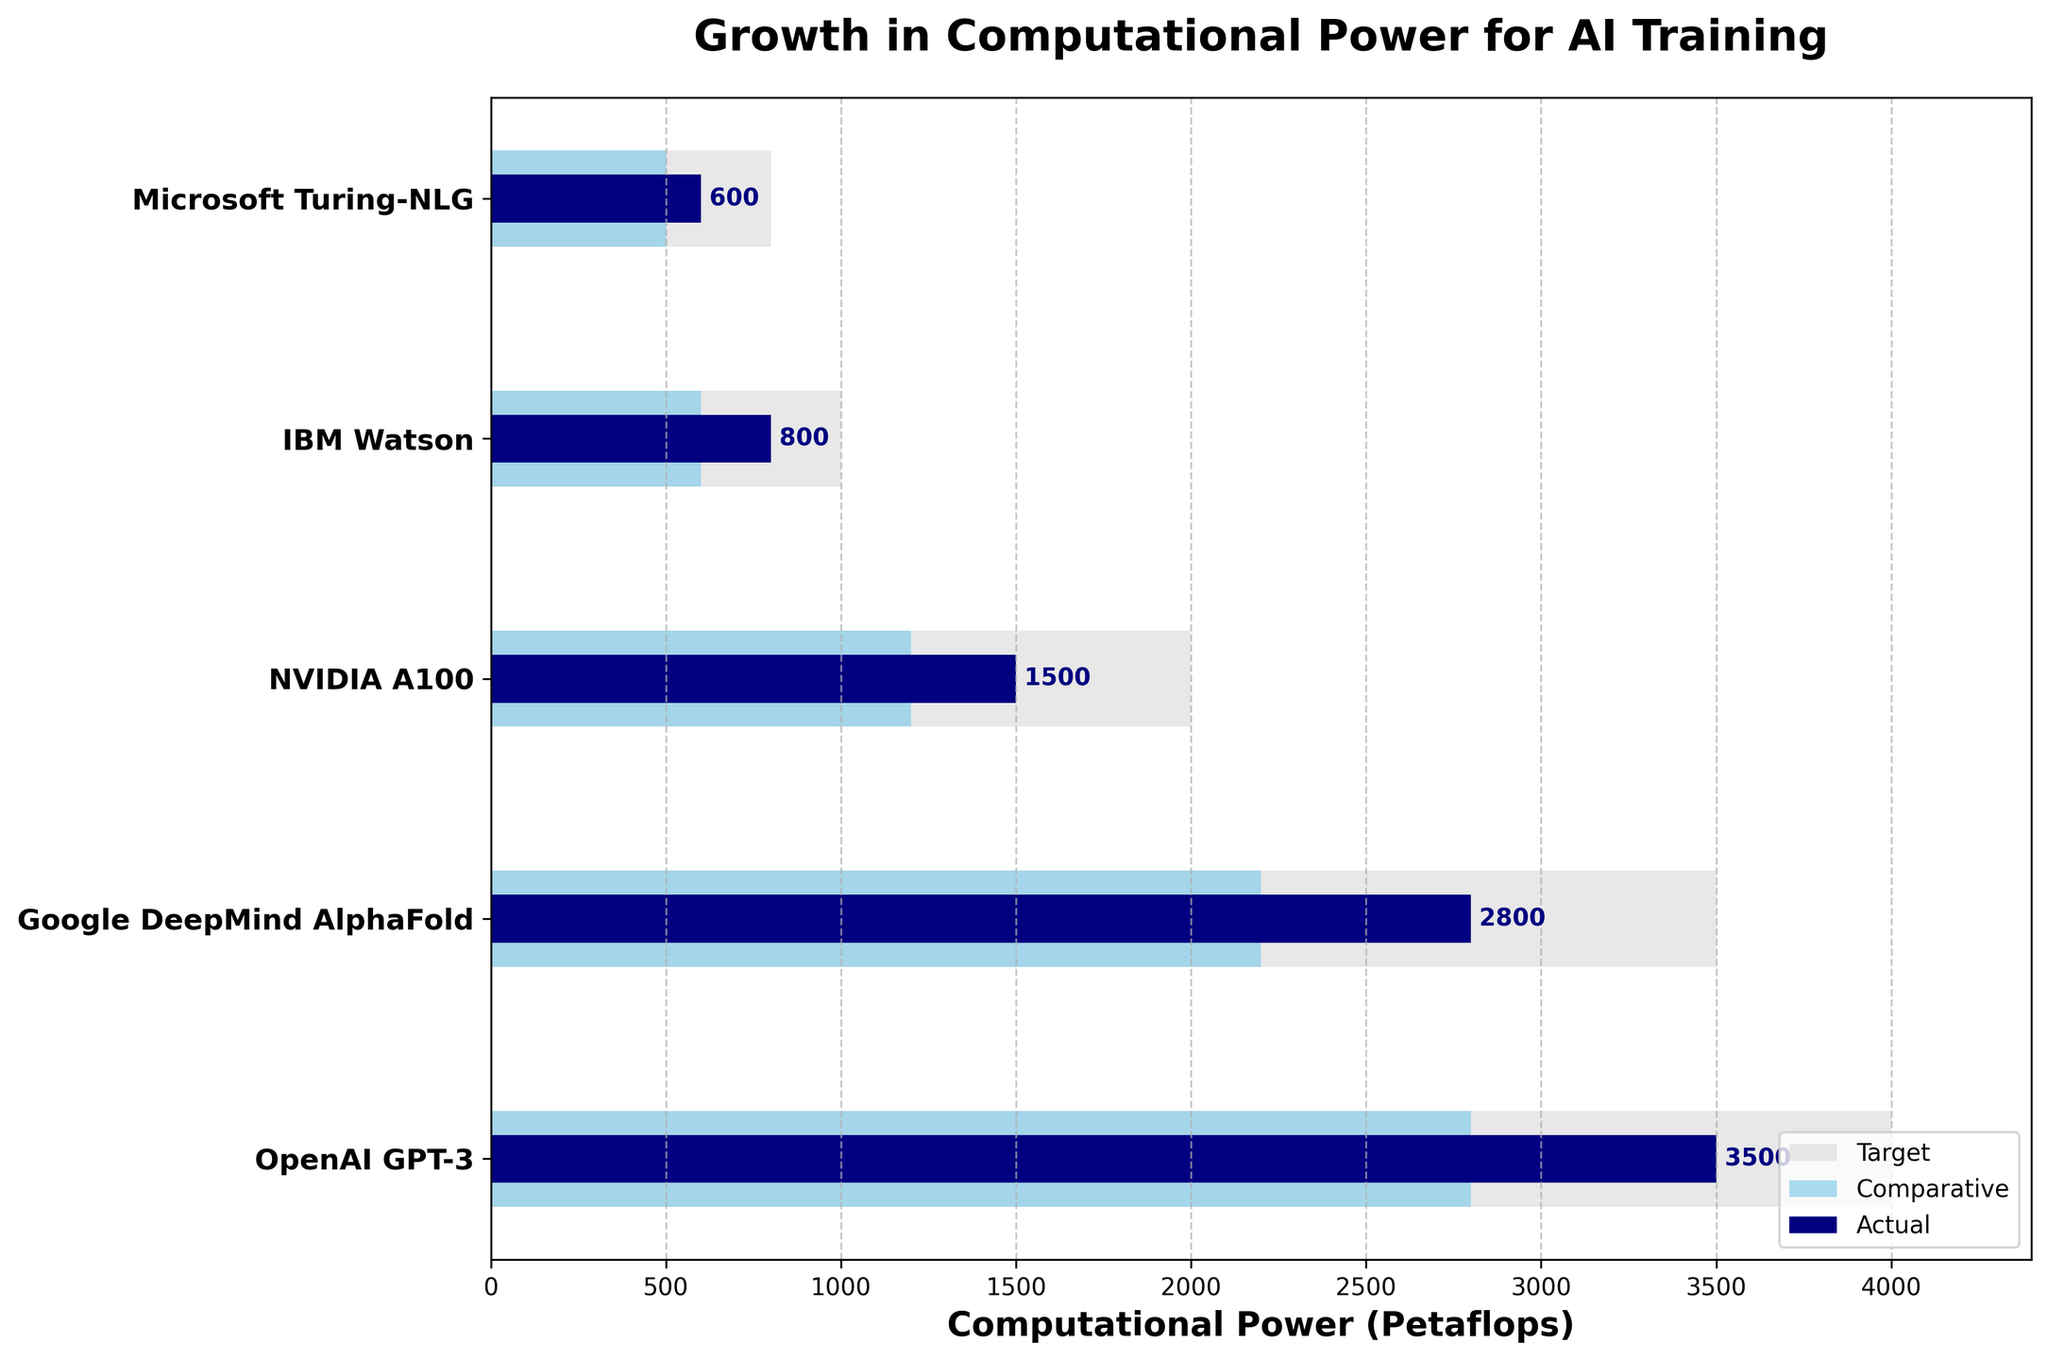How many features are represented in the chart? Count the number of unique data points displayed on the y-axis. There are five distinct features mentioned: OpenAI GPT-3, Google DeepMind AlphaFold, NVIDIA A100, IBM Watson, and Microsoft Turing-NLG.
Answer: 5 Which AI project has the highest actual computational power usage? Look at the bar representing actual computational power (navy color) for each feature. The longest bar in this category is for OpenAI GPT-3 at 3500 petaflops.
Answer: OpenAI GPT-3 What is the difference between the target and actual computational power for IBM Watson? Subtract the actual value from the target value for IBM Watson. The target is 1000 petaflops and the actual is 800 petaflops. 1000 - 800 = 200 petaflops.
Answer: 200 petaflops Compare the comparative computational power usage of Google DeepMind AlphaFold and Microsoft Turing-NLG. Which one is higher and by how much? Google DeepMind AlphaFold has a comparative computational power of 2200 petaflops, whereas Microsoft Turing-NLG has 500 petaflops. Subtract the two to find the difference: 2200 - 500 = 1700 petaflops.
Answer: Google DeepMind AlphaFold by 1700 petaflops What is the average target computational power for all listed features? Sum the target computational power values (4000 + 3500 + 2000 + 1000 + 800) which equals 11300, then divide by the number of features (5). 11300 / 5 = 2260 petaflops.
Answer: 2260 petaflops Is the actual computational power used by any feature equal to its comparative computational power? Compare the actual and comparative values for each feature. None of the features have equal values for actual and comparative computational power.
Answer: No Which AI project has not yet reached its target computational power but is closest to achieving it? Calculate the differences between target and actual computational power for each feature: OpenAI GPT-3 (500), Google DeepMind AlphaFold (700), NVIDIA A100 (500), IBM Watson (200), Microsoft Turing-NLG (200). The smallest difference is for IBM Watson and Microsoft Turing-NLG, both at 200 petaflops. Therefore, we need to further compare their actual values; IBM Watson (800 petaflops) has the highest actual value closest to its target.
Answer: IBM Watson For which feature is the gap between comparative and actual computational power largest? Calculate the differences between comparative and actual values for all features: OpenAI GPT-3 (2800 - 3500 = 700), Google DeepMind AlphaFold (2200 - 2800 = 600), NVIDIA A100 (1200 - 1500 = 300), IBM Watson (600 - 800 = 200), Microsoft Turing-NLG (500 - 600 = 100). The largest gap is 700 for OpenAI GPT-3.
Answer: OpenAI GPT-3 What is the total computational power target for OpenAI GPT-3 and Google DeepMind AlphaFold combined? Add the target values of OpenAI GPT-3 and Google DeepMind AlphaFold. 4000 (GPT-3) + 3500 (AlphaFold) = 7500 petaflops.
Answer: 7500 petaflops 